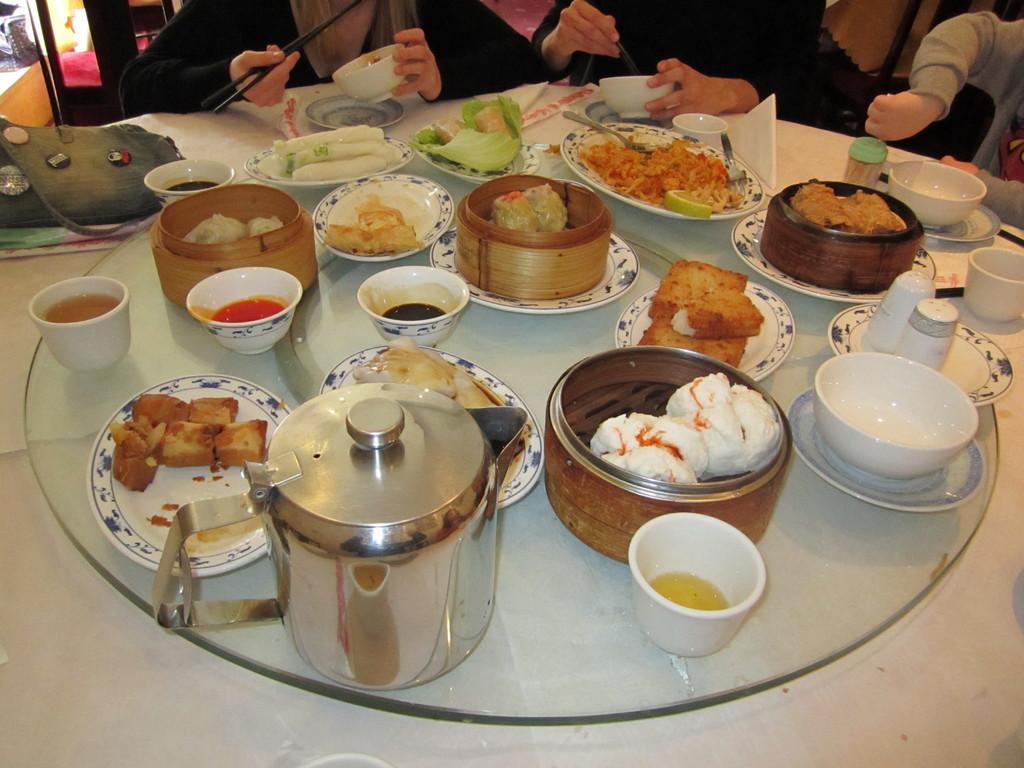How would you summarize this image in a sentence or two? In this image we can see food items in the bowls, kettle, plates, bottles, tissue papers, chopsticks, and few objects on a table. At the top of the image we can see people who are truncated. 